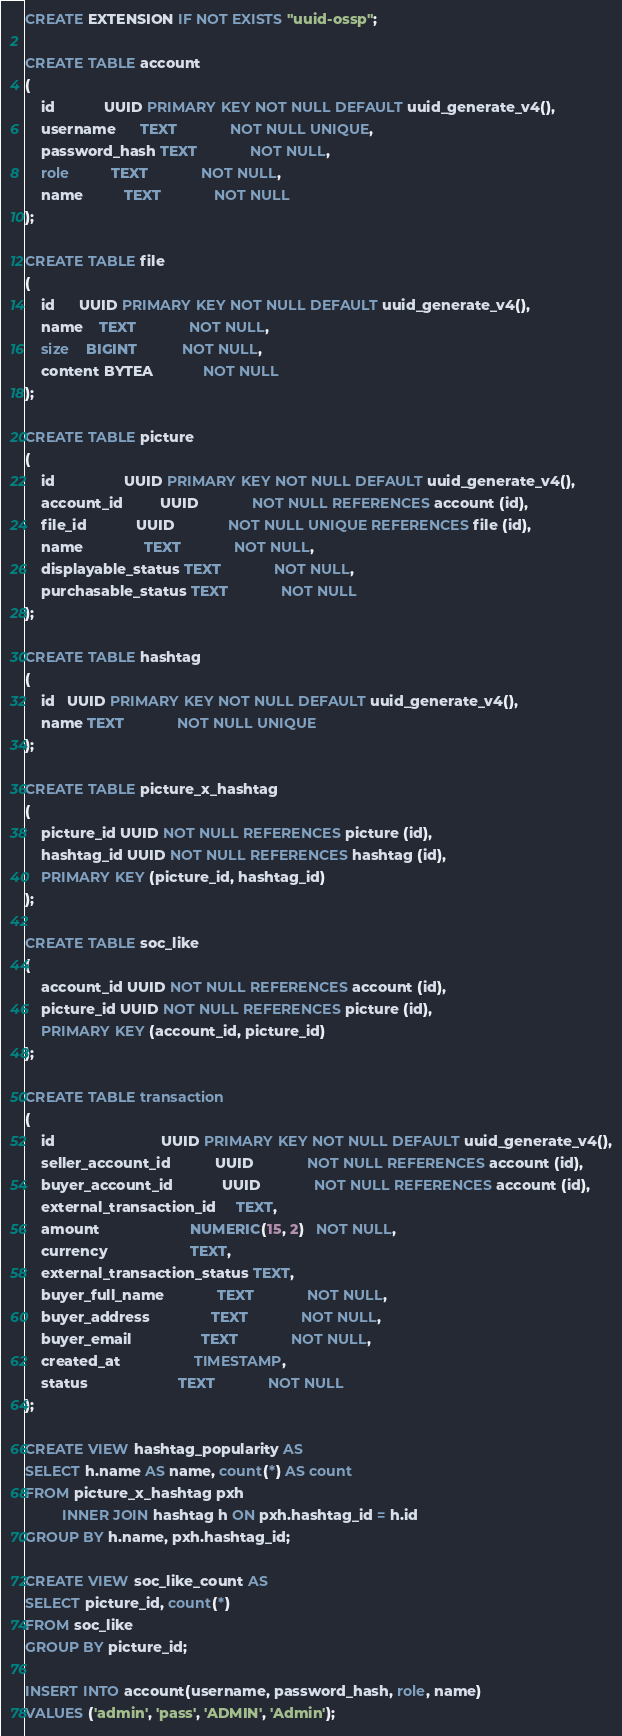Convert code to text. <code><loc_0><loc_0><loc_500><loc_500><_SQL_>CREATE EXTENSION IF NOT EXISTS "uuid-ossp";

CREATE TABLE account
(
    id            UUID PRIMARY KEY NOT NULL DEFAULT uuid_generate_v4(),
    username      TEXT             NOT NULL UNIQUE,
    password_hash TEXT             NOT NULL,
    role          TEXT             NOT NULL,
    name          TEXT             NOT NULL
);

CREATE TABLE file
(
    id      UUID PRIMARY KEY NOT NULL DEFAULT uuid_generate_v4(),
    name    TEXT             NOT NULL,
    size    BIGINT           NOT NULL,
    content BYTEA            NOT NULL
);

CREATE TABLE picture
(
    id                 UUID PRIMARY KEY NOT NULL DEFAULT uuid_generate_v4(),
    account_id         UUID             NOT NULL REFERENCES account (id),
    file_id            UUID             NOT NULL UNIQUE REFERENCES file (id),
    name               TEXT             NOT NULL,
    displayable_status TEXT             NOT NULL,
    purchasable_status TEXT             NOT NULL
);

CREATE TABLE hashtag
(
    id   UUID PRIMARY KEY NOT NULL DEFAULT uuid_generate_v4(),
    name TEXT             NOT NULL UNIQUE
);

CREATE TABLE picture_x_hashtag
(
    picture_id UUID NOT NULL REFERENCES picture (id),
    hashtag_id UUID NOT NULL REFERENCES hashtag (id),
    PRIMARY KEY (picture_id, hashtag_id)
);

CREATE TABLE soc_like
(
    account_id UUID NOT NULL REFERENCES account (id),
    picture_id UUID NOT NULL REFERENCES picture (id),
    PRIMARY KEY (account_id, picture_id)
);

CREATE TABLE transaction
(
    id                          UUID PRIMARY KEY NOT NULL DEFAULT uuid_generate_v4(),
    seller_account_id           UUID             NOT NULL REFERENCES account (id),
    buyer_account_id            UUID             NOT NULL REFERENCES account (id),
    external_transaction_id     TEXT,
    amount                      NUMERIC(15, 2)   NOT NULL,
    currency                    TEXT,
    external_transaction_status TEXT,
    buyer_full_name             TEXT             NOT NULL,
    buyer_address               TEXT             NOT NULL,
    buyer_email                 TEXT             NOT NULL,
    created_at                  TIMESTAMP,
    status                      TEXT             NOT NULL
);

CREATE VIEW hashtag_popularity AS
SELECT h.name AS name, count(*) AS count
FROM picture_x_hashtag pxh
         INNER JOIN hashtag h ON pxh.hashtag_id = h.id
GROUP BY h.name, pxh.hashtag_id;

CREATE VIEW soc_like_count AS
SELECT picture_id, count(*)
FROM soc_like
GROUP BY picture_id;

INSERT INTO account(username, password_hash, role, name)
VALUES ('admin', 'pass', 'ADMIN', 'Admin');</code> 